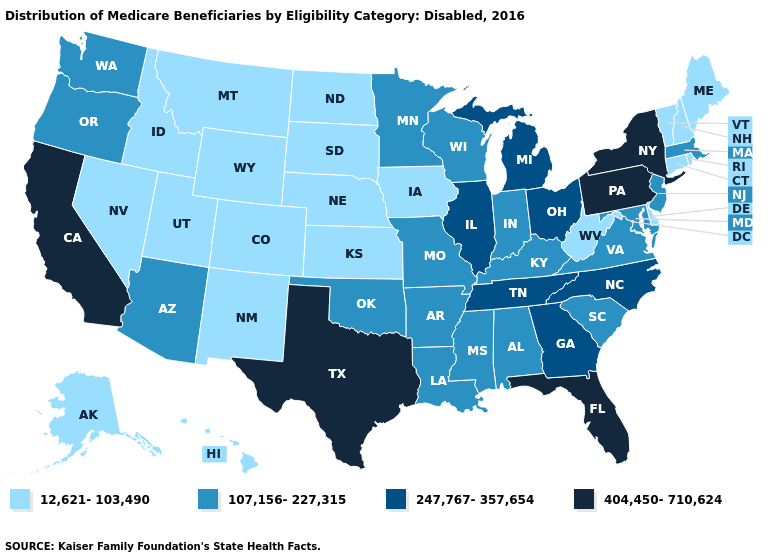Does Virginia have a higher value than Florida?
Quick response, please. No. What is the lowest value in the Northeast?
Quick response, please. 12,621-103,490. What is the value of Idaho?
Give a very brief answer. 12,621-103,490. Does Pennsylvania have the lowest value in the Northeast?
Concise answer only. No. Name the states that have a value in the range 404,450-710,624?
Answer briefly. California, Florida, New York, Pennsylvania, Texas. What is the highest value in the USA?
Answer briefly. 404,450-710,624. Which states have the lowest value in the South?
Short answer required. Delaware, West Virginia. Name the states that have a value in the range 404,450-710,624?
Be succinct. California, Florida, New York, Pennsylvania, Texas. What is the lowest value in the USA?
Concise answer only. 12,621-103,490. Is the legend a continuous bar?
Quick response, please. No. Name the states that have a value in the range 12,621-103,490?
Keep it brief. Alaska, Colorado, Connecticut, Delaware, Hawaii, Idaho, Iowa, Kansas, Maine, Montana, Nebraska, Nevada, New Hampshire, New Mexico, North Dakota, Rhode Island, South Dakota, Utah, Vermont, West Virginia, Wyoming. Name the states that have a value in the range 12,621-103,490?
Write a very short answer. Alaska, Colorado, Connecticut, Delaware, Hawaii, Idaho, Iowa, Kansas, Maine, Montana, Nebraska, Nevada, New Hampshire, New Mexico, North Dakota, Rhode Island, South Dakota, Utah, Vermont, West Virginia, Wyoming. Does Louisiana have a higher value than Maine?
Answer briefly. Yes. Which states have the highest value in the USA?
Concise answer only. California, Florida, New York, Pennsylvania, Texas. Does Delaware have a lower value than Rhode Island?
Quick response, please. No. 